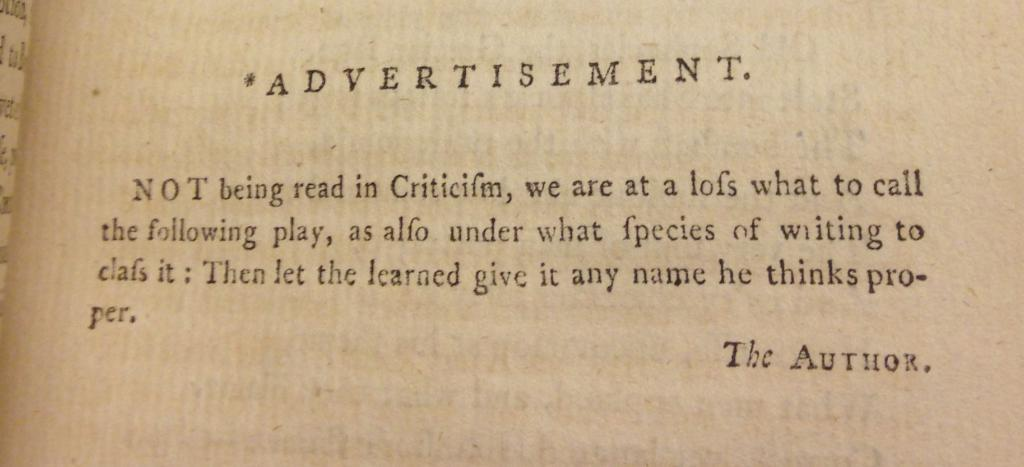What is present in the image that can be written or printed on? There is a paper in the image. What can be found on the paper in the image? The paper has text on it. What type of toy is being used to generate heat in the image? There is no toy or heat generation present in the image; it only features a paper with text on it. 